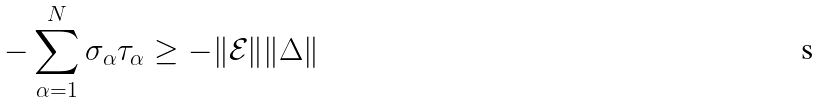Convert formula to latex. <formula><loc_0><loc_0><loc_500><loc_500>- \sum _ { \alpha = 1 } ^ { N } \sigma _ { \alpha } \tau _ { \alpha } \geq - \| \mathcal { E } \| \| \Delta \|</formula> 